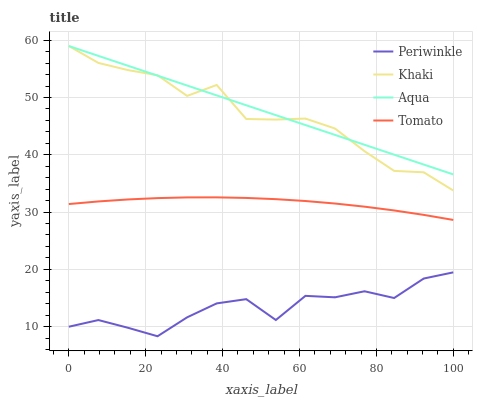Does Periwinkle have the minimum area under the curve?
Answer yes or no. Yes. Does Aqua have the maximum area under the curve?
Answer yes or no. Yes. Does Khaki have the minimum area under the curve?
Answer yes or no. No. Does Khaki have the maximum area under the curve?
Answer yes or no. No. Is Aqua the smoothest?
Answer yes or no. Yes. Is Periwinkle the roughest?
Answer yes or no. Yes. Is Khaki the smoothest?
Answer yes or no. No. Is Khaki the roughest?
Answer yes or no. No. Does Khaki have the lowest value?
Answer yes or no. No. Does Periwinkle have the highest value?
Answer yes or no. No. Is Periwinkle less than Aqua?
Answer yes or no. Yes. Is Aqua greater than Periwinkle?
Answer yes or no. Yes. Does Periwinkle intersect Aqua?
Answer yes or no. No. 